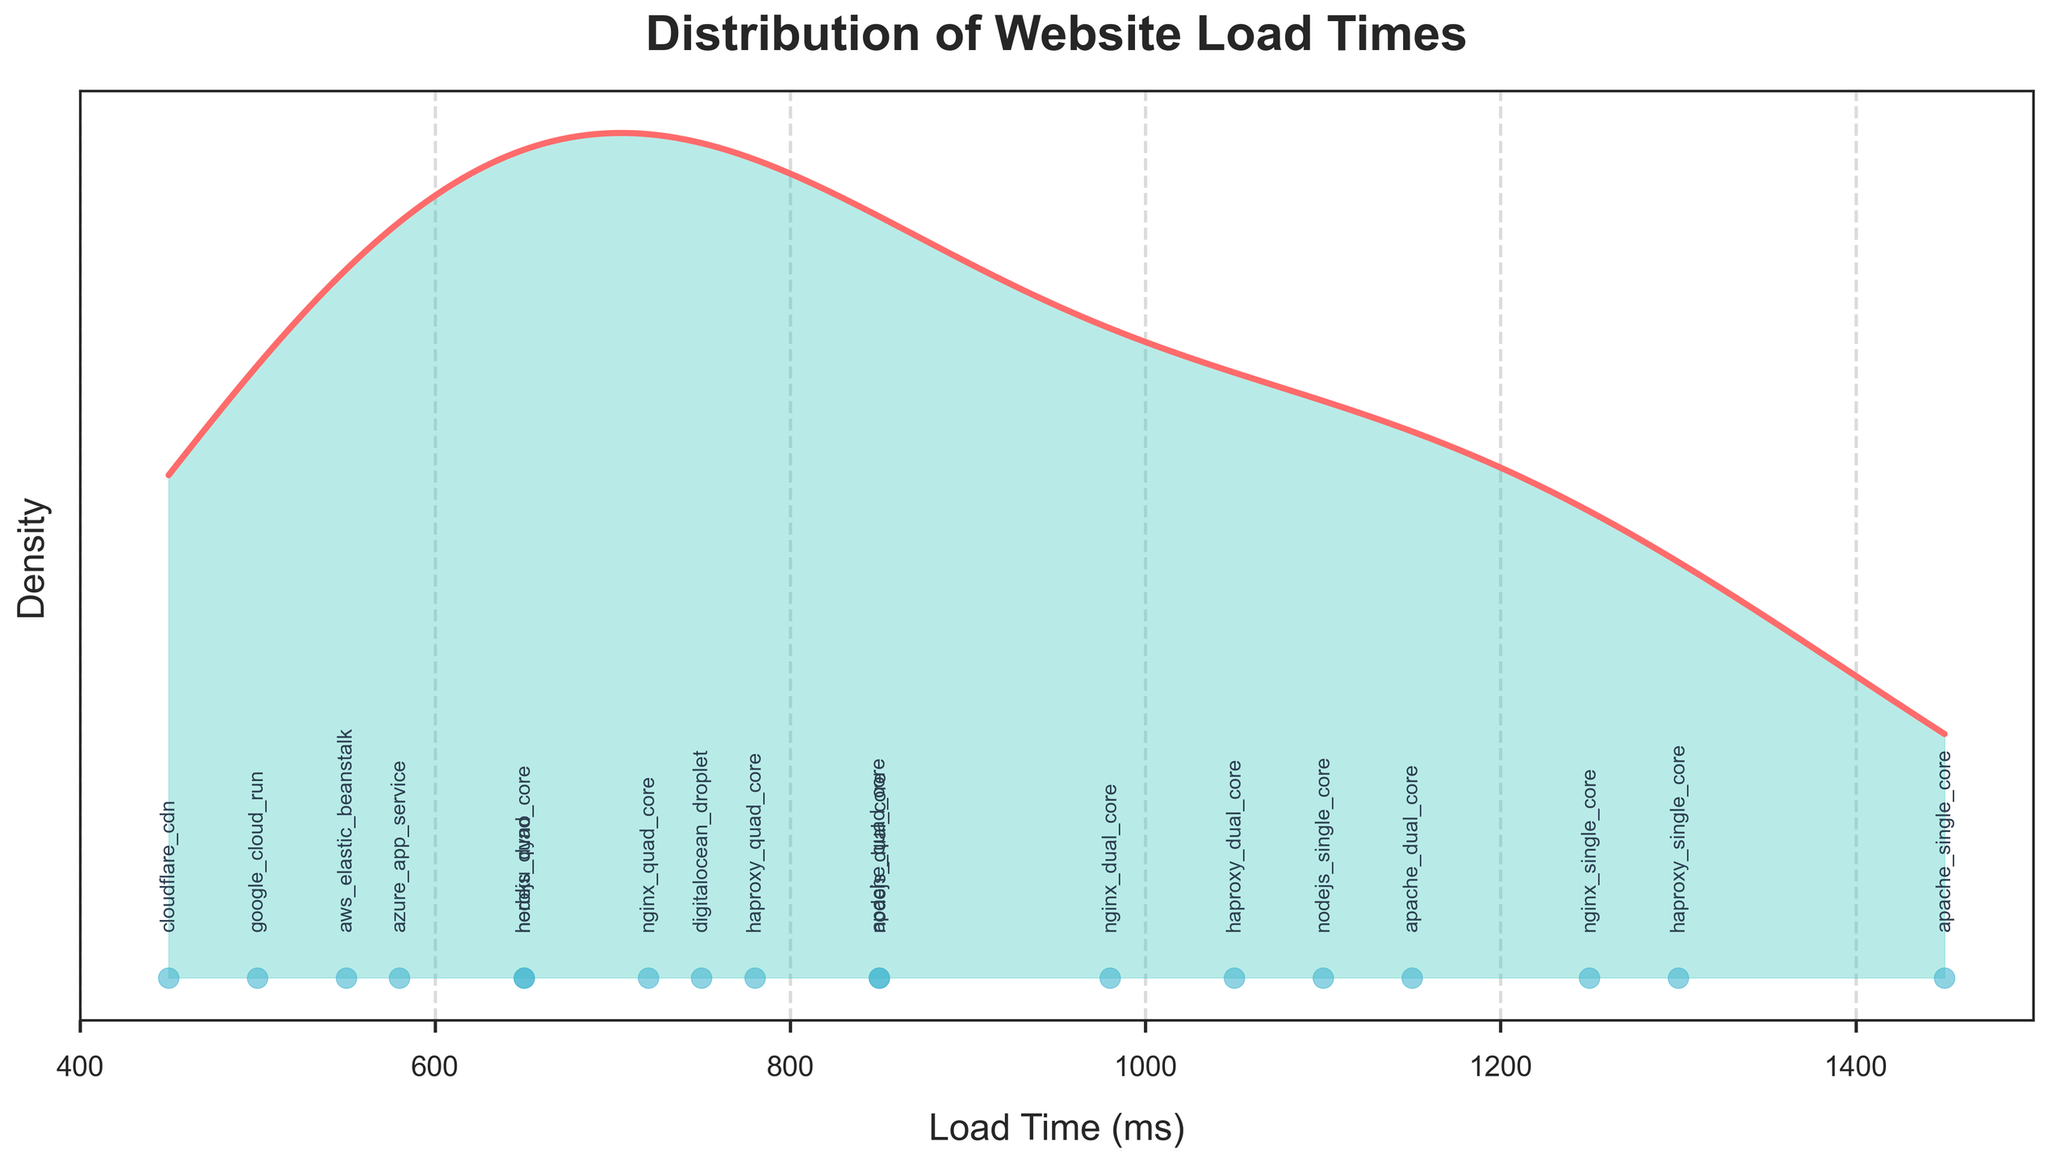What is the title of the plot? The title of the plot is usually the largest text and is located at the top of the figure. It summarizes what the plot is about.
Answer: Distribution of Website Load Times How many server configurations are annotated in the plot? Each server configuration is represented by a label on the plot. Count the unique labels present.
Answer: 16 What is the approximate load time of the fastest server configuration? Locate the left-most data point on the density plot, as it represents the shortest load time.
Answer: 450 ms Which server configuration has the shortest load time? The annotation near the shortest load time point on the x-axis will indicate the server configuration.
Answer: cloudflare_cdn How does the load time of nginx_dual_core compare to nodejs_dual_core? Identify the positions of nginx_dual_core and nodejs_dual_core annotations on the x-axis and compare their values.
Answer: nginx_dual_core is slower Which group of server configurations (single, dual, or quad core) generally has the longest load times? Look at the distribution of load times for the server configurations specified with single, dual, or quad core and identify the group with the highest values.
Answer: single core What is the range of load times displayed in the plot? Determine the minimum and maximum values on the x-axis to find the range of load times.
Answer: 450 ms to 1450 ms Which server configuration is identified with a load time closest to the average of the displayed load times? Calculate the average (mean) load time from the plot and find the nearest annotation to this value on the x-axis.
Answer: azure_app_service What does the color fill between the density curve and x-axis represent? The filled area under the density curve typically represents the distribution of the data points across the range of x-values, indicating where data points are more concentrated.
Answer: Data concentration How does the density for load times around 500 ms compare to load times around 1000 ms? Compare the height of the density curve at both 500 ms and 1000 ms. This will indicate the relative density of data points at these values.
Answer: Higher for 500 ms 